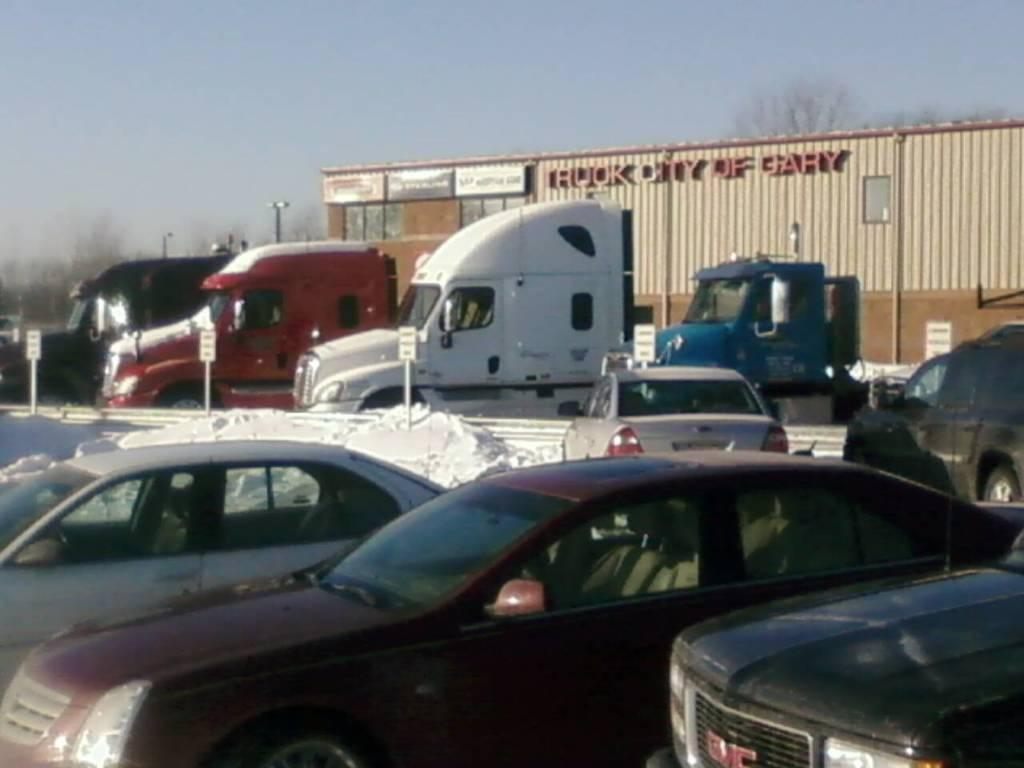What can be seen in the image that moves or transports people or goods? There are vehicles in the image. What is written or displayed on the ground in the image? There are boards with text on the ground. What is located in the background of the image? There is a shed with text and trees are visible in the background. What part of the natural environment can be seen in the image? The sky is visible in the background. What type of leather material is draped over the vase in the image? There is no leather or vase present in the image. How does the fog affect the visibility of the vehicles in the image? There is no fog present in the image; the sky is visible in the background. 